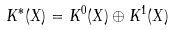<formula> <loc_0><loc_0><loc_500><loc_500>K ^ { \ast } ( X ) = K ^ { 0 } ( X ) \oplus K ^ { 1 } ( X )</formula> 